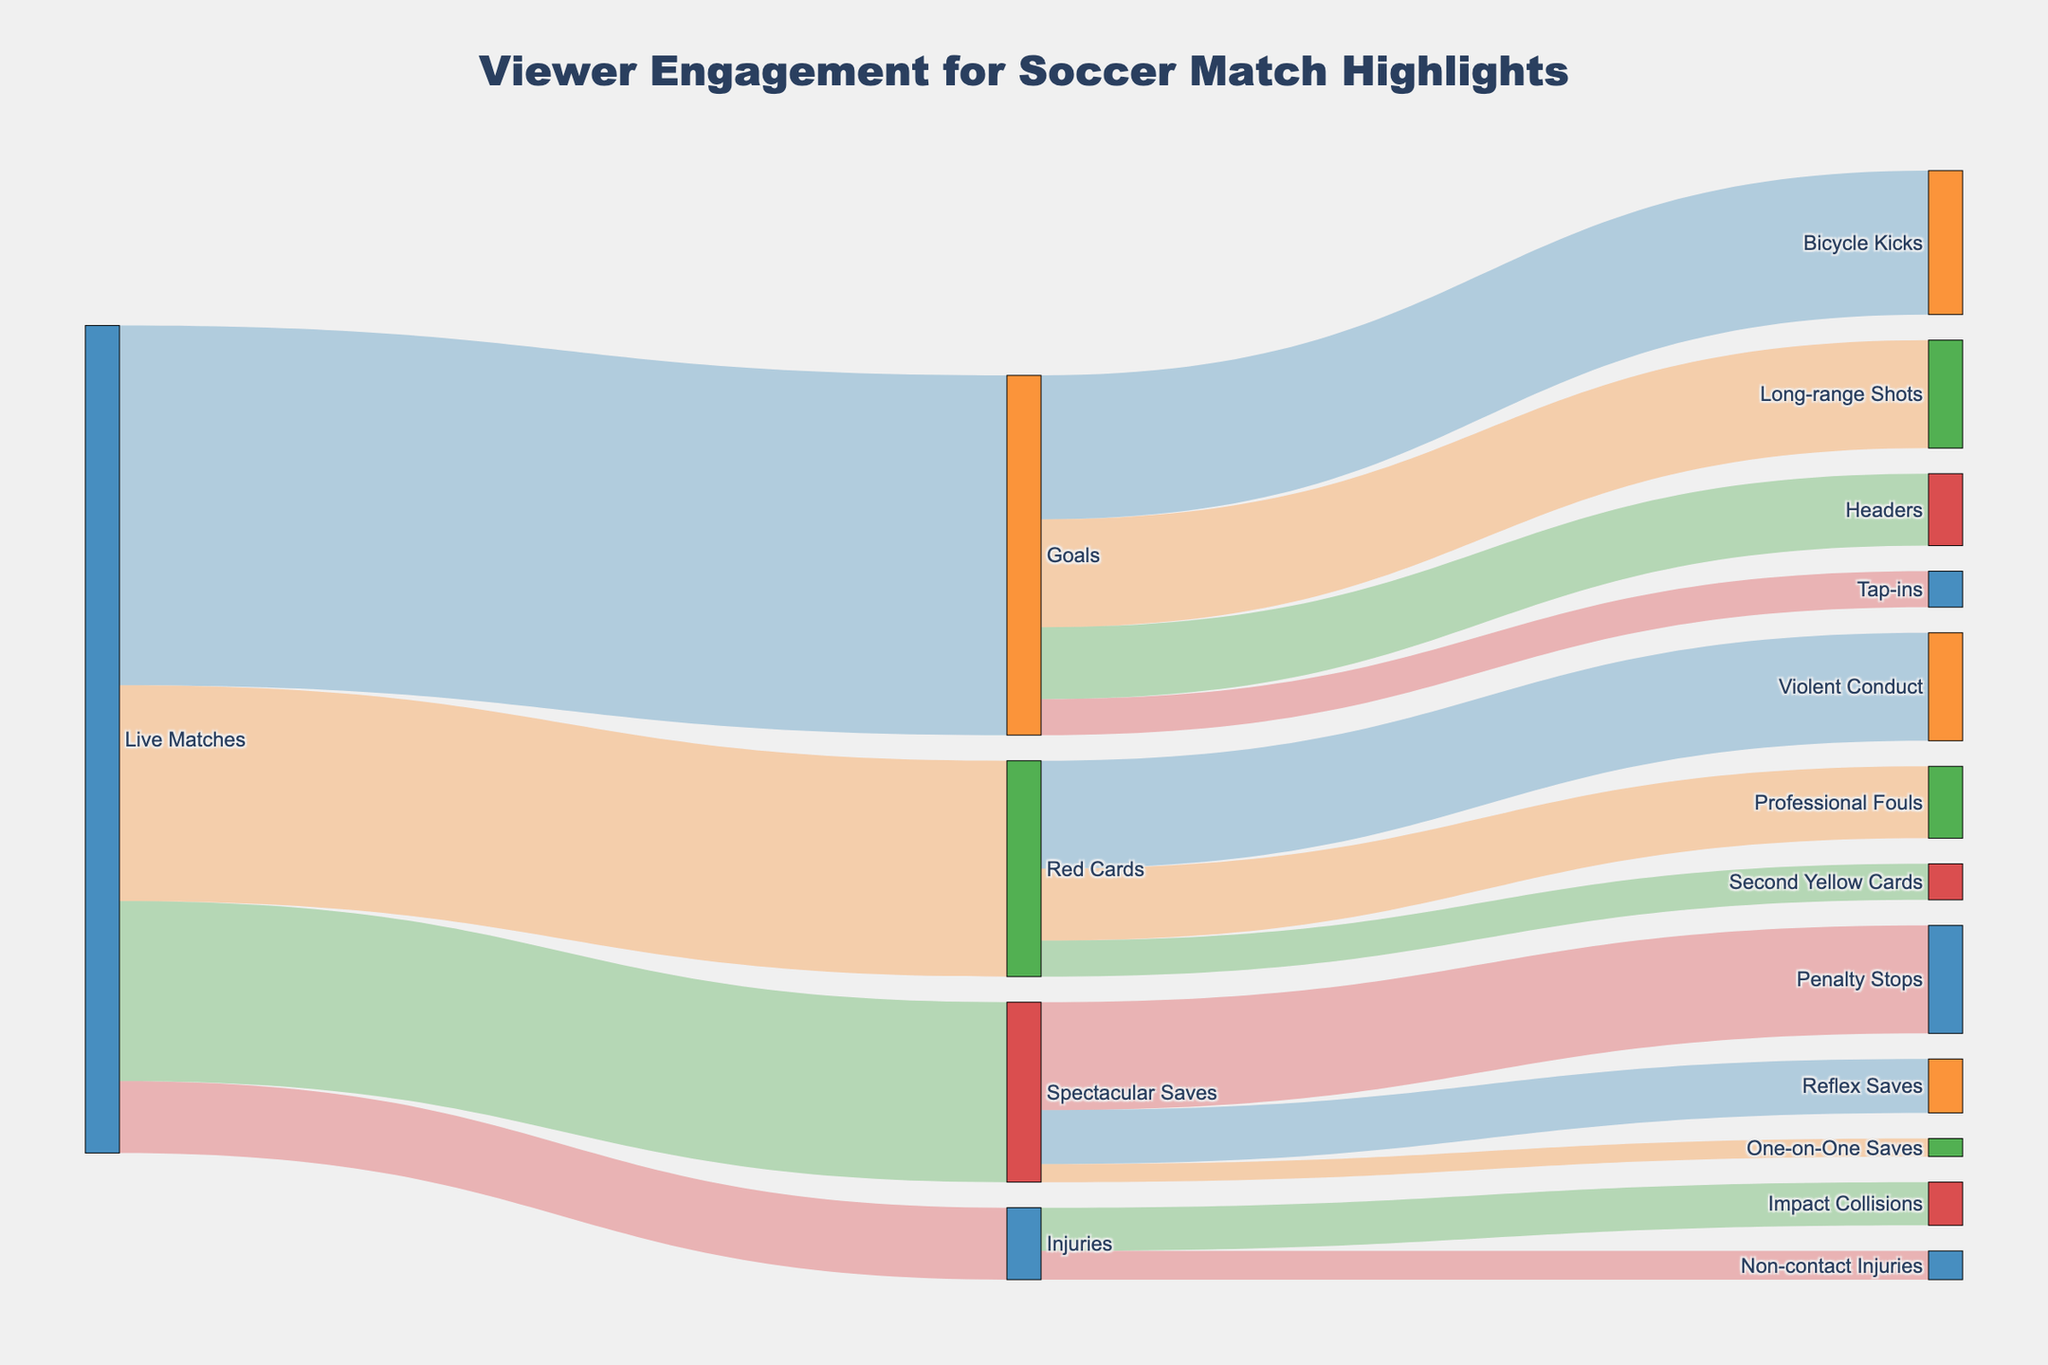What is the title of the Sankey Diagram? The title of the Sankey Diagram is usually displayed prominently and can be easily read from the top of the figure.
Answer: Viewer Engagement for Soccer Match Highlights How many viewers engaged with live matches? Examination of the diagram reveals separate flows for live matches leading to different highlight types. Adding these values gives the total engagement for live matches.
Answer: 1,150,000 Which specific highlight under "Goals" attracted the highest number of viewers? By inspecting the diagram flows from "Goals," the viewer numbers for each specific highlight can be compared.
Answer: Bicycle Kicks Compare the engagement for "Red Cards" and "Spectacular Saves." Which highlight has more viewers? Total viewers for "Red Cards" can be compared with total viewers for "Spectacular Saves" by summing the respective flows.
Answer: Red Cards What is the total number of viewers for "Goals"? The total viewers for "Goals" can be determined by summing the viewers of all specific goal types under it.
Answer: 500,000 What type of injury highlight attracted more viewers, "Impact Collisions" or "Non-contact Injuries"? The viewer numbers can be directly compared by inspecting the flows from "Injuries" to both types.
Answer: Impact Collisions What is the sum of viewers for highlights under "Spectacular Saves"? To find this, viewers for "Penalty Stops," "Reflex Saves," and "One-on-One Saves" are summed up.
Answer: 250,000 What is the combined viewer count for "Long-range Shots" and "Headers" under "Goals"? Add viewer numbers for "Long-range Shots" and "Headers" by observing their individual flows.
Answer: 250,000 How does the viewership of "Second Yellow Cards" compare to "Tap-ins"? Compare the viewer numbers for "Second Yellow Cards" under "Red Cards" and "Tap-ins" under "Goals".
Answer: Tap-ins Which specific goal type had the least viewer engagement? The smallest value under the "Goals" flows can be identified to find the goal type with the least viewers.
Answer: Tap-ins 